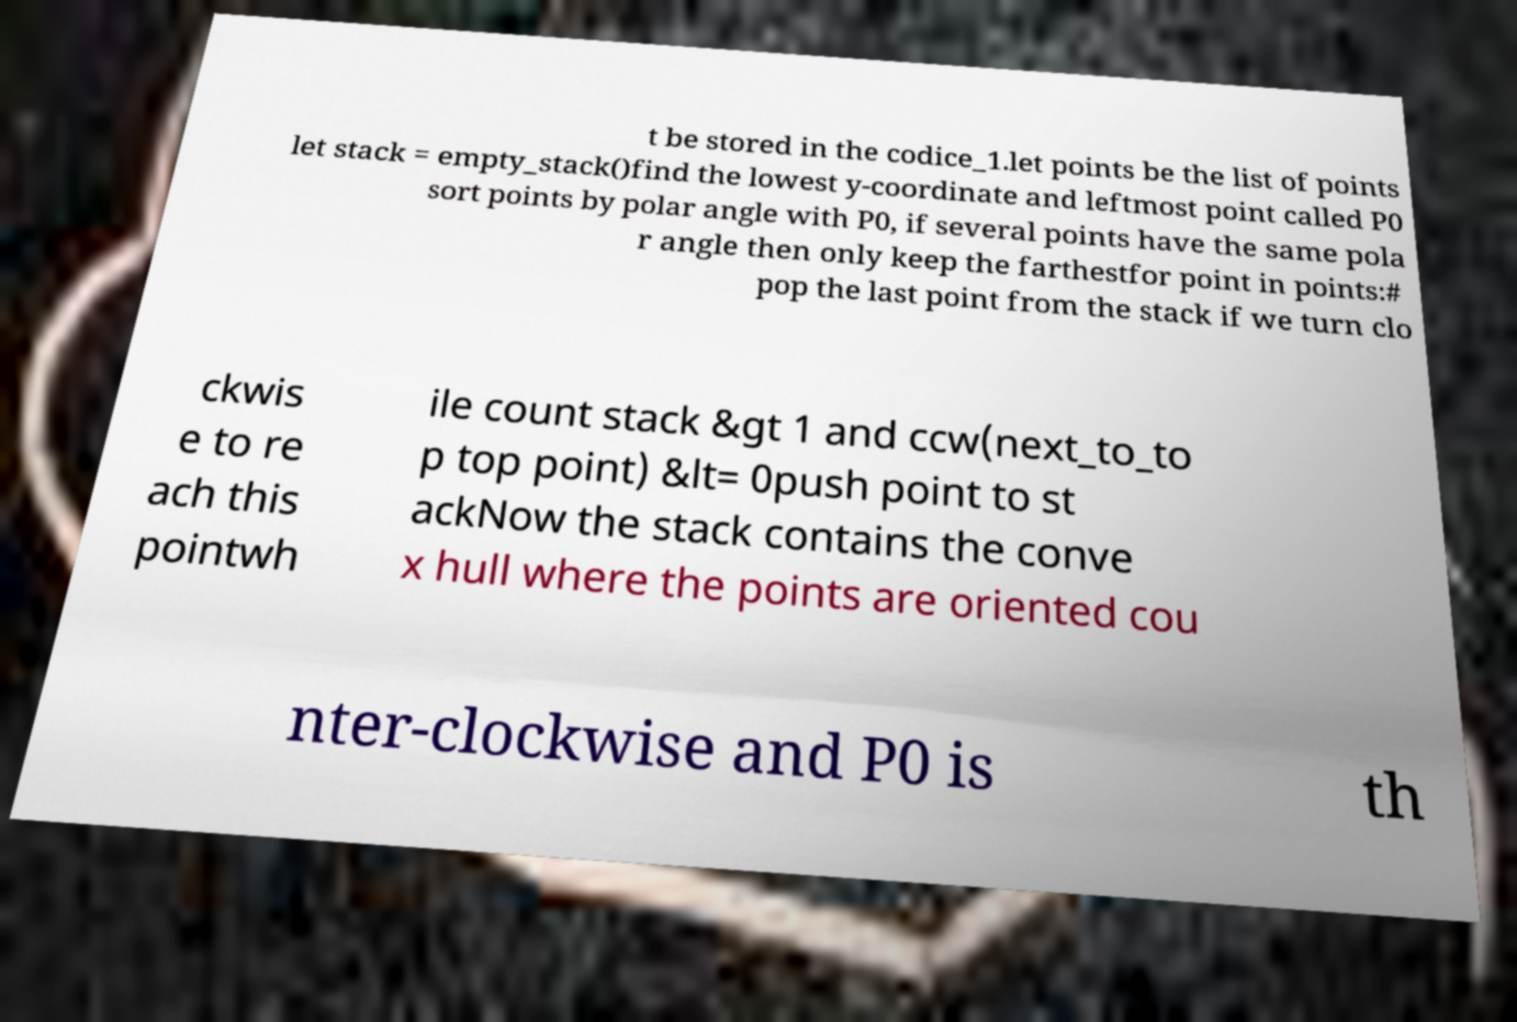Could you extract and type out the text from this image? t be stored in the codice_1.let points be the list of points let stack = empty_stack()find the lowest y-coordinate and leftmost point called P0 sort points by polar angle with P0, if several points have the same pola r angle then only keep the farthestfor point in points:# pop the last point from the stack if we turn clo ckwis e to re ach this pointwh ile count stack &gt 1 and ccw(next_to_to p top point) &lt= 0push point to st ackNow the stack contains the conve x hull where the points are oriented cou nter-clockwise and P0 is th 